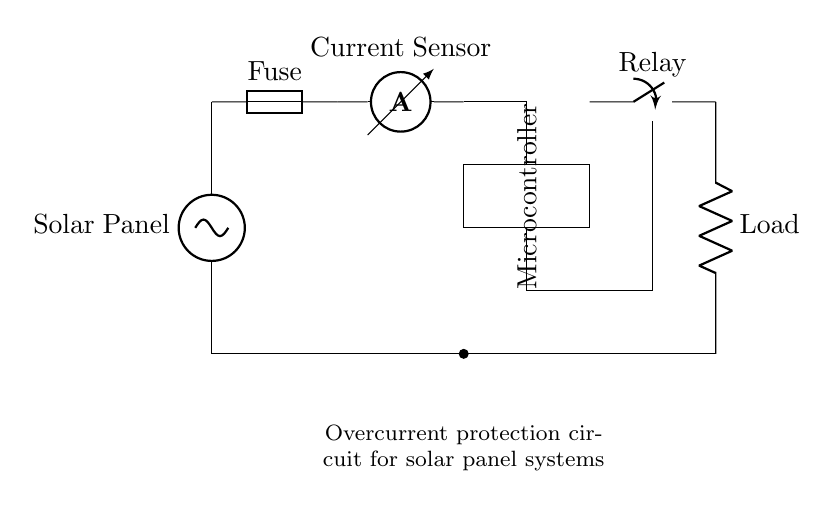What is the role of the fuse in this circuit? The fuse serves as a protective device that interrupts the circuit when excessive current flows, preventing damage to other components.
Answer: Protective device What is the component that measures current? The current sensor measures the flow of current within the circuit, providing feedback to the microcontroller about the current levels.
Answer: Current sensor How many main components are visible in this circuit? The circuit consists of five main components: the solar panel, fuse, current sensor, microcontroller, and relay.
Answer: Five What action does the relay perform in this circuit? The relay acts as a switch that controls the connection to the load, allowing or interrupting the flow of current based on the microcontroller's commands.
Answer: Switch What will likely happen if the current exceeds the rated limit? If the current exceeds the rated limit, the fuse will blow or disconnect to prevent wire overload and protect downstream components from damage.
Answer: Fuse blows What is the primary purpose of the microcontroller in this circuit? The microcontroller processes data from the current sensor and controls the relay to turn the load on or off, ensuring safe operation within current limits.
Answer: Control unit 